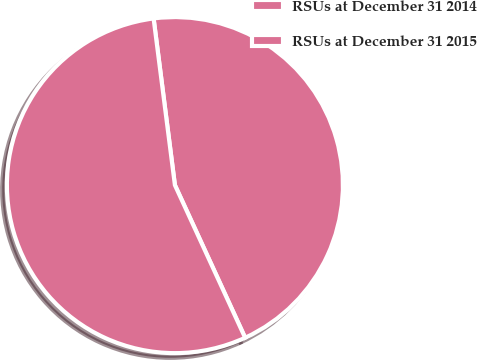Convert chart to OTSL. <chart><loc_0><loc_0><loc_500><loc_500><pie_chart><fcel>RSUs at December 31 2014<fcel>RSUs at December 31 2015<nl><fcel>45.16%<fcel>54.84%<nl></chart> 